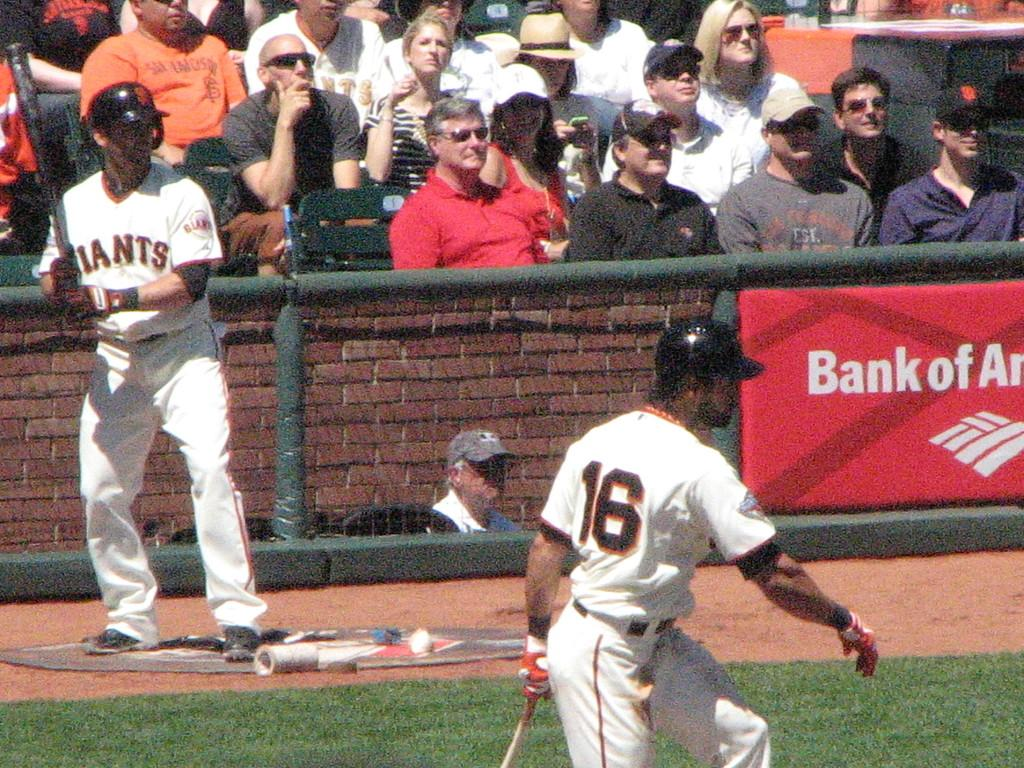Provide a one-sentence caption for the provided image. A baseball player is wearing number 16 on his jersey. 